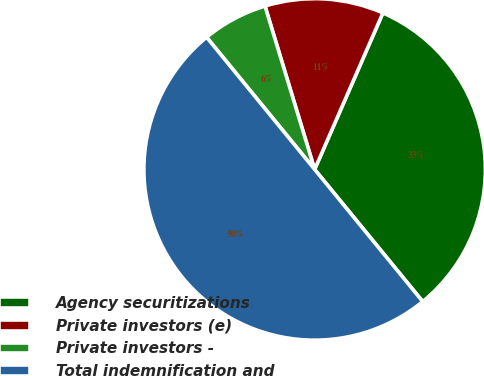Convert chart. <chart><loc_0><loc_0><loc_500><loc_500><pie_chart><fcel>Agency securitizations<fcel>Private investors (e)<fcel>Private investors -<fcel>Total indemnification and<nl><fcel>32.54%<fcel>11.24%<fcel>6.21%<fcel>50.0%<nl></chart> 